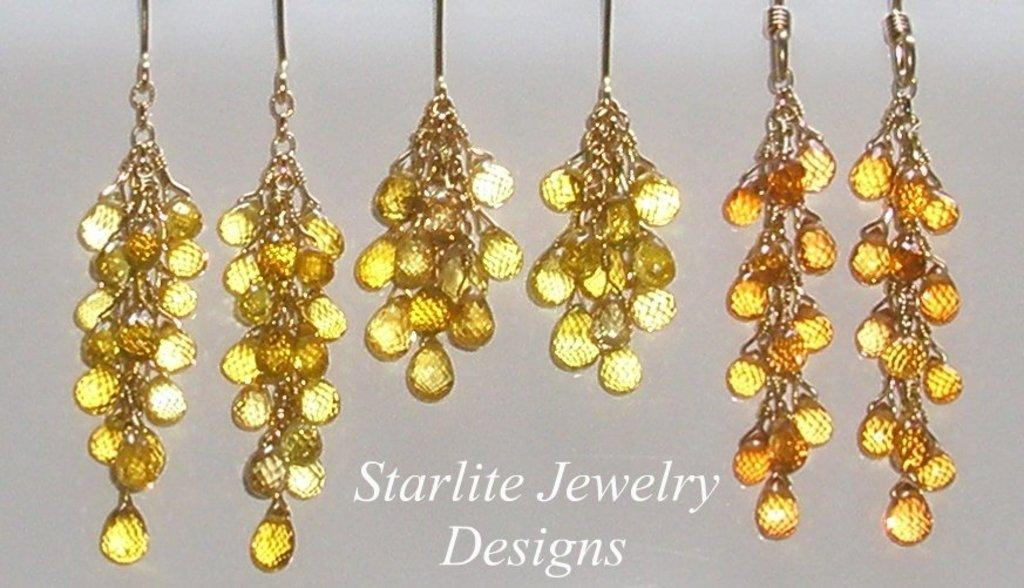What types of objects can be seen in the image? There are decorative items in the image. Can you describe what is written at the bottom of the image? Unfortunately, the specific content of the writing cannot be determined from the provided facts. What is the purpose or function of the decorative items in the image? The purpose or function of the decorative items cannot be determined from the provided facts. How many baseballs can be seen in the image? There is no mention of baseballs in the provided facts, so it cannot be determined if any are present in the image. 